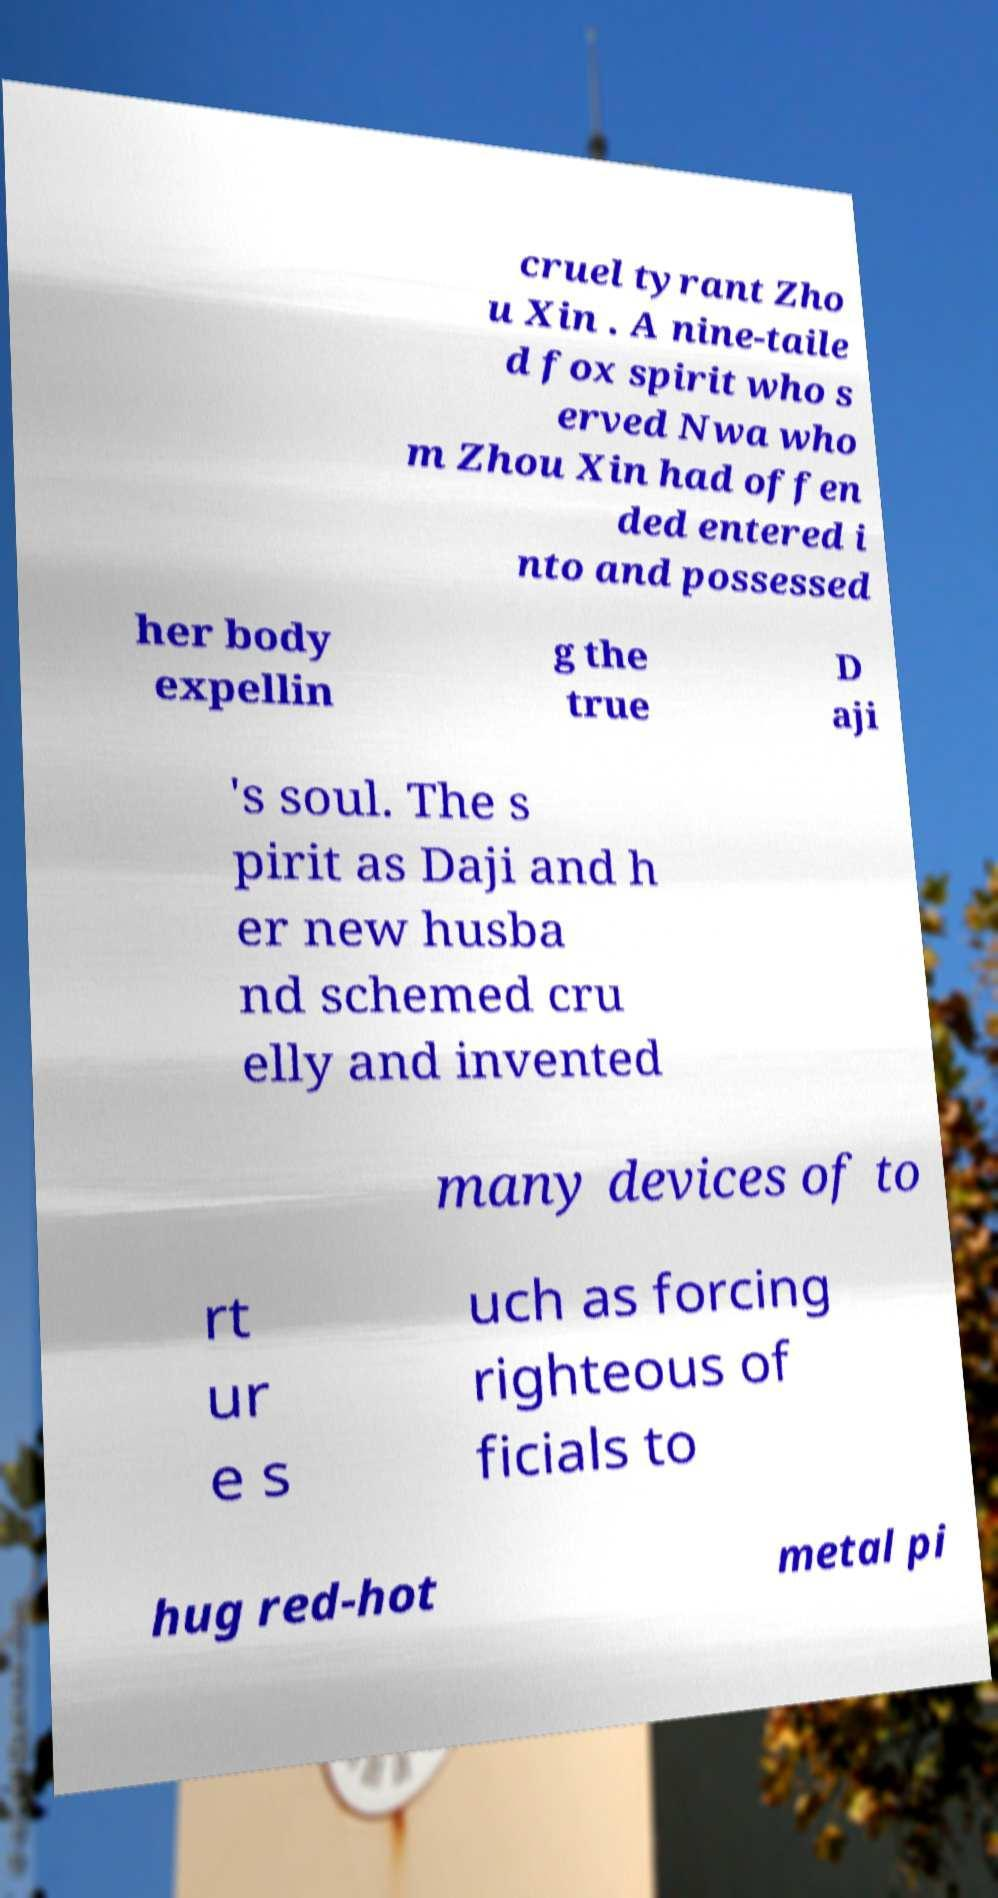There's text embedded in this image that I need extracted. Can you transcribe it verbatim? cruel tyrant Zho u Xin . A nine-taile d fox spirit who s erved Nwa who m Zhou Xin had offen ded entered i nto and possessed her body expellin g the true D aji 's soul. The s pirit as Daji and h er new husba nd schemed cru elly and invented many devices of to rt ur e s uch as forcing righteous of ficials to hug red-hot metal pi 